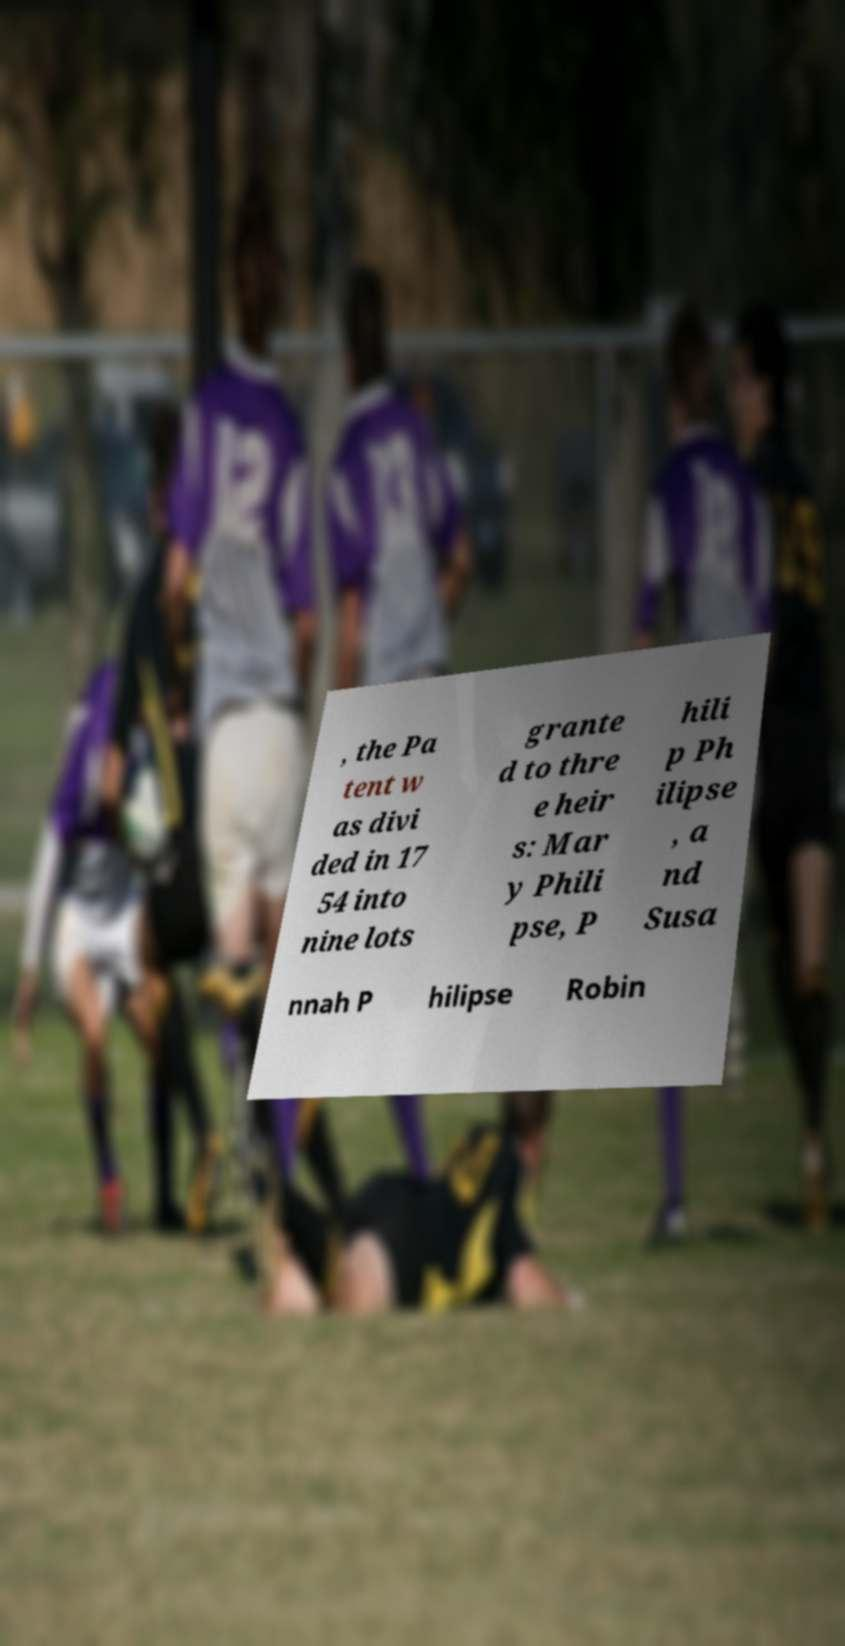For documentation purposes, I need the text within this image transcribed. Could you provide that? , the Pa tent w as divi ded in 17 54 into nine lots grante d to thre e heir s: Mar y Phili pse, P hili p Ph ilipse , a nd Susa nnah P hilipse Robin 